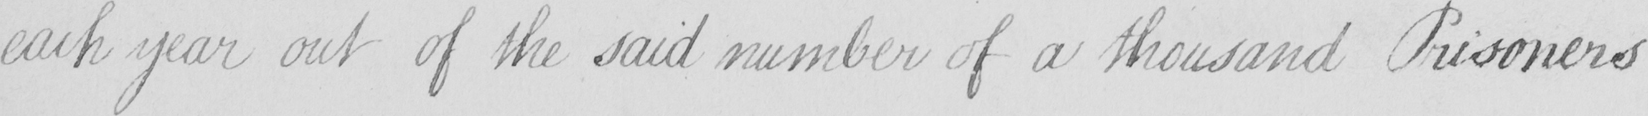What does this handwritten line say? each year out of the said number of a thousand Prisoners 